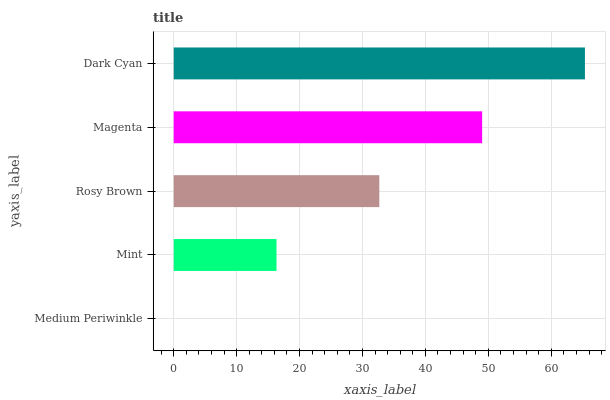Is Medium Periwinkle the minimum?
Answer yes or no. Yes. Is Dark Cyan the maximum?
Answer yes or no. Yes. Is Mint the minimum?
Answer yes or no. No. Is Mint the maximum?
Answer yes or no. No. Is Mint greater than Medium Periwinkle?
Answer yes or no. Yes. Is Medium Periwinkle less than Mint?
Answer yes or no. Yes. Is Medium Periwinkle greater than Mint?
Answer yes or no. No. Is Mint less than Medium Periwinkle?
Answer yes or no. No. Is Rosy Brown the high median?
Answer yes or no. Yes. Is Rosy Brown the low median?
Answer yes or no. Yes. Is Magenta the high median?
Answer yes or no. No. Is Medium Periwinkle the low median?
Answer yes or no. No. 